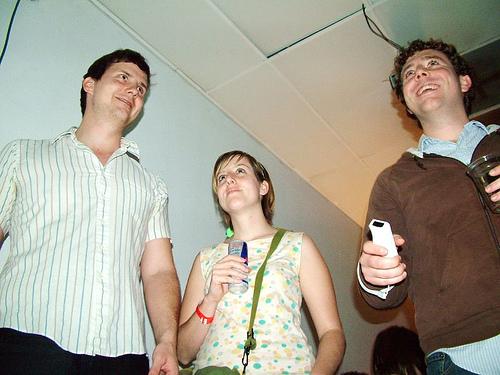What color is the women's dress?
Be succinct. White. Are they happy?
Write a very short answer. Yes. Which are has a pink strap?
Write a very short answer. None. What color is the man's shirt?
Keep it brief. Brown. What is the woman drinking?
Short answer required. Red bull. How many people have wristbands on their arms?
Give a very brief answer. 2. 